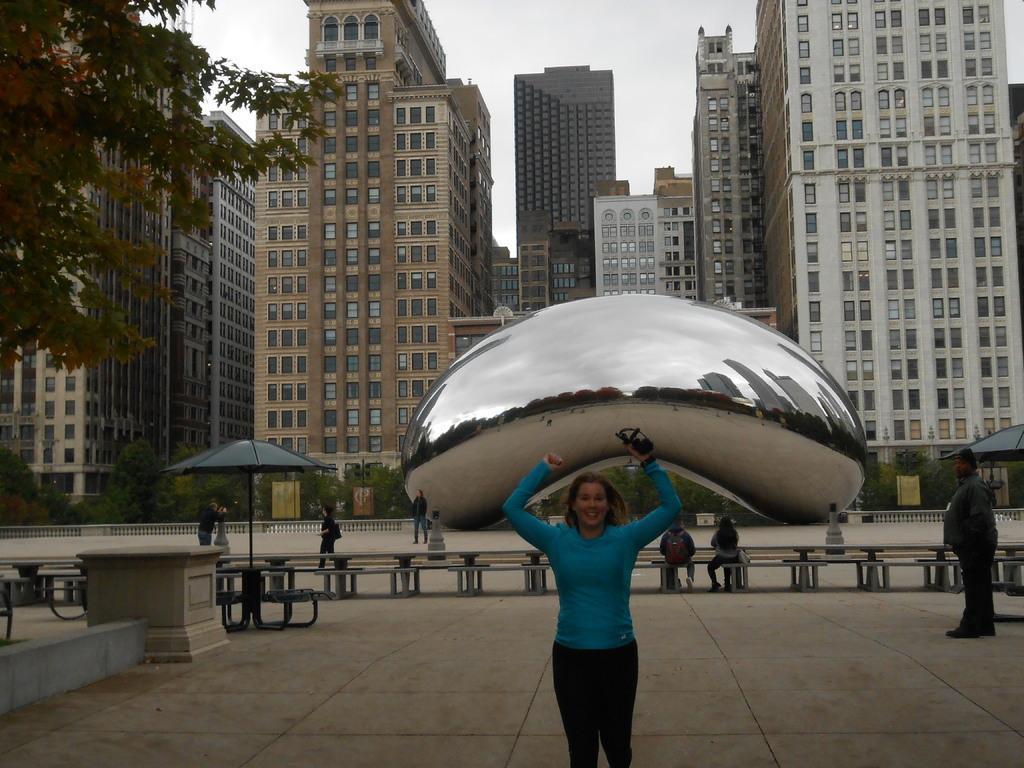Could you give a brief overview of what you see in this image? In this picture we can see group of people, few are sitting and few are standing, on the left side of the image we can see an umbrella, in the background we can find few trees, buildings and a sculpture. 